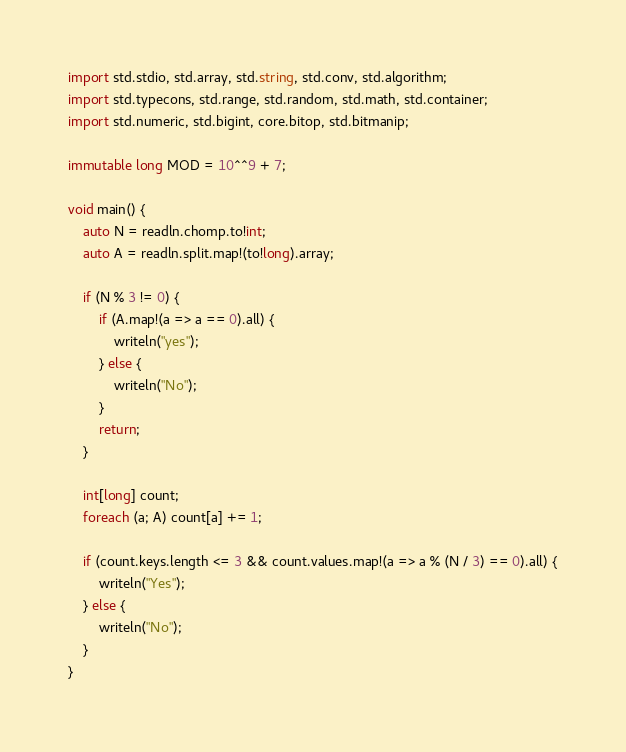Convert code to text. <code><loc_0><loc_0><loc_500><loc_500><_D_>import std.stdio, std.array, std.string, std.conv, std.algorithm;
import std.typecons, std.range, std.random, std.math, std.container;
import std.numeric, std.bigint, core.bitop, std.bitmanip;

immutable long MOD = 10^^9 + 7;

void main() {
    auto N = readln.chomp.to!int;
    auto A = readln.split.map!(to!long).array;

    if (N % 3 != 0) {
        if (A.map!(a => a == 0).all) {
            writeln("yes");
        } else {
            writeln("No");
        }
        return;
    }

    int[long] count;
    foreach (a; A) count[a] += 1;

    if (count.keys.length <= 3 && count.values.map!(a => a % (N / 3) == 0).all) {
        writeln("Yes");
    } else {
        writeln("No");
    }
}</code> 